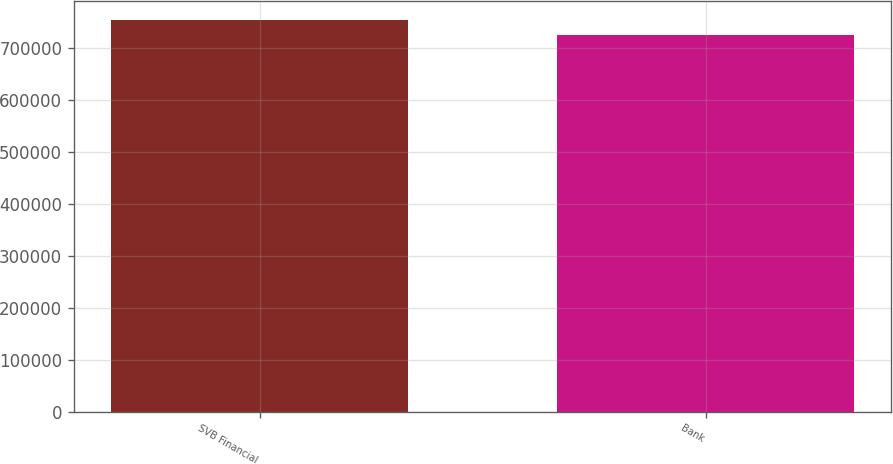Convert chart to OTSL. <chart><loc_0><loc_0><loc_500><loc_500><bar_chart><fcel>SVB Financial<fcel>Bank<nl><fcel>752534<fcel>723832<nl></chart> 